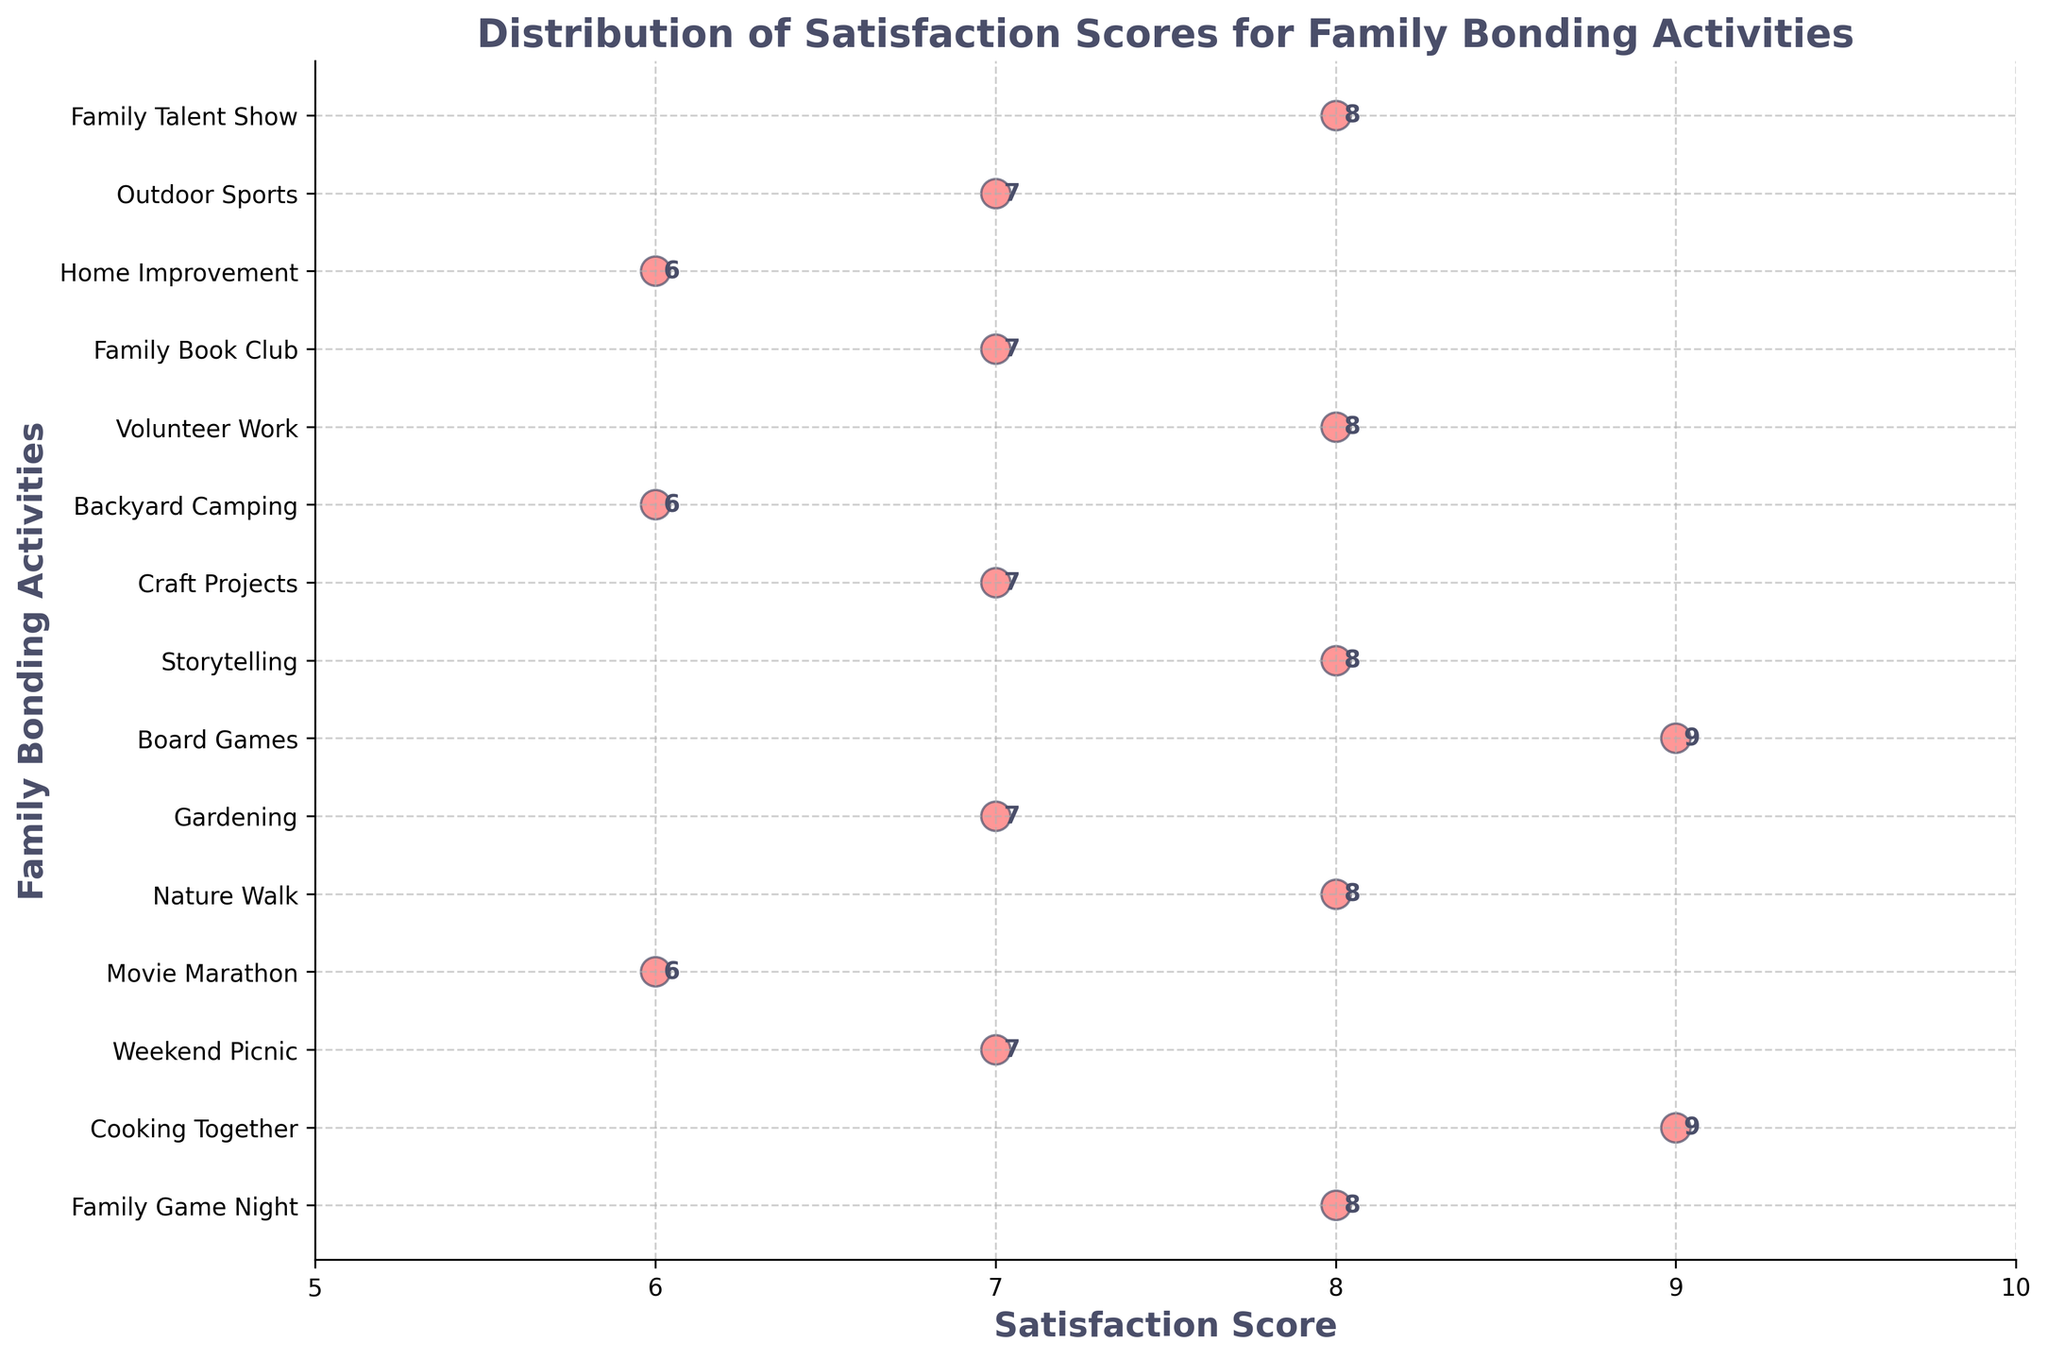What is the title of the plot? The title of the plot is often found at the top of the chart, summarizing what the visual data represents.
Answer: Distribution of Satisfaction Scores for Family Bonding Activities What is the highest satisfaction score for any activity? Find the highest value on the x-axis (Satisfaction Score) and identify the corresponding activity. The highest score depicted is '9'.
Answer: 9 Which family bonding activity has the lowest satisfaction score? Identify the lowest point on the x-axis, which is 6. Then look across to see the corresponding labels for this score.
Answer: Movie Marathon, Backyard Camping, Home Improvement How many activities have a satisfaction score of 8 or higher? Count the data points on the x-axis that are 8 or above. These scores are 8, 8, 8, 8, 9, 9, which makes 6 activities.
Answer: 6 What is the median satisfaction score? First, list the satisfaction scores in numerical order: 6, 6, 6, 7, 7, 7, 7, 7, 8, 8, 8, 8, 9, 9. The median is the middle value of the ordered list, which has 15 scores, so the median value is the 8th score.
Answer: 7 Which activity has the satisfaction score of 7 and involves physical outdoor engagement? Out of the activities with a satisfaction score of 7, identify the one associated with being outside.
Answer: Outdoor Sports How many more activities have a score of 8 compared to 6? Count the activities for each score. There are four activities with a score of 8 and three with a score of 6. Subtract the counts.
Answer: 1 What is the range of satisfaction scores for the activities? The range is calculated by subtracting the smallest score from the largest score. Here, it's 9 - 6.
Answer: 3 What activity has the same satisfaction score as "Gardening"? Look at the satisfaction score for "Gardening", which is 7, and find another activity with the same score.
Answer: Family Book Club, Craft Projects, Weekend Picnic 